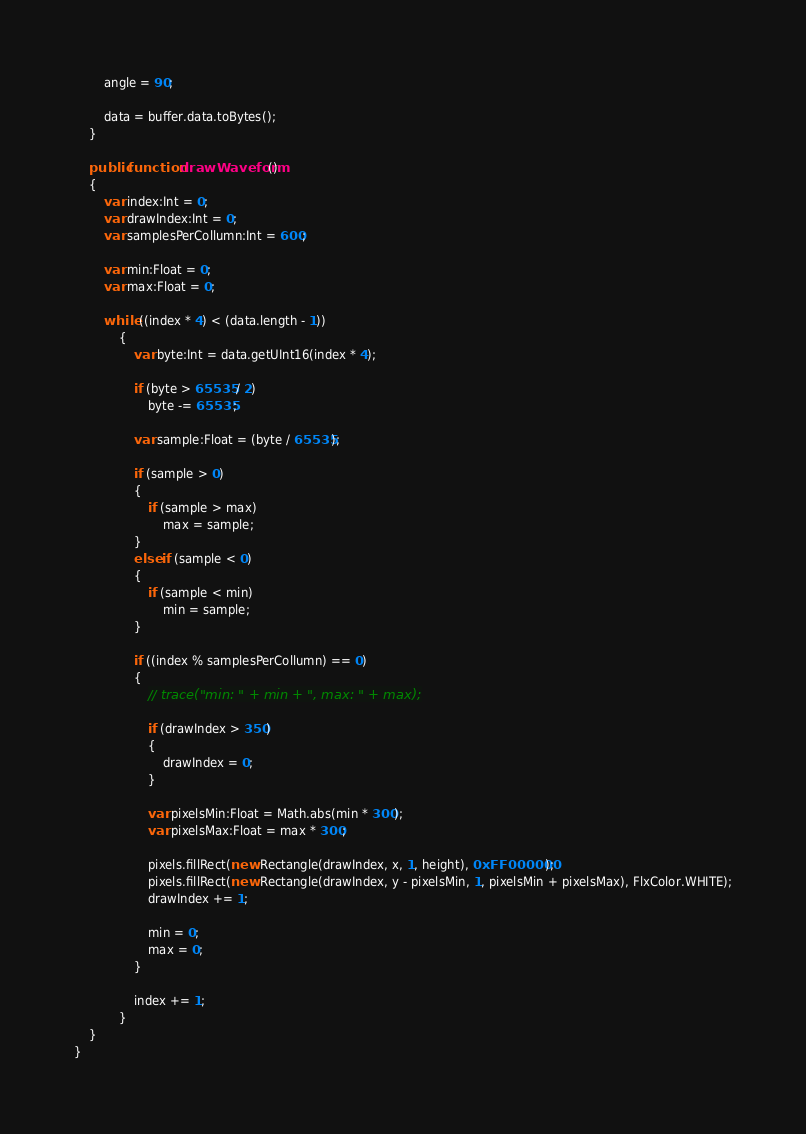<code> <loc_0><loc_0><loc_500><loc_500><_Haxe_>
        angle = 90;

        data = buffer.data.toBytes();
    }

    public function drawWaveform()
    {
		var index:Int = 0;
		var drawIndex:Int = 0;
		var samplesPerCollumn:Int = 600;

		var min:Float = 0;
		var max:Float = 0;

        while ((index * 4) < (data.length - 1))
			{
				var byte:Int = data.getUInt16(index * 4);

				if (byte > 65535 / 2)
					byte -= 65535;

				var sample:Float = (byte / 65535);

				if (sample > 0)
				{
					if (sample > max)
						max = sample;
				}
				else if (sample < 0)
				{
					if (sample < min)
						min = sample;
				}

                if ((index % samplesPerCollumn) == 0)
				{
					// trace("min: " + min + ", max: " + max);

					if (drawIndex > 350)
					{
						drawIndex = 0;
					}

					var pixelsMin:Float = Math.abs(min * 300);
					var pixelsMax:Float = max * 300;

					pixels.fillRect(new Rectangle(drawIndex, x, 1, height), 0xFF000000);
					pixels.fillRect(new Rectangle(drawIndex, y - pixelsMin, 1, pixelsMin + pixelsMax), FlxColor.WHITE);
					drawIndex += 1;

					min = 0;
					max = 0;
				}

				index += 1;
			}
    }
}</code> 